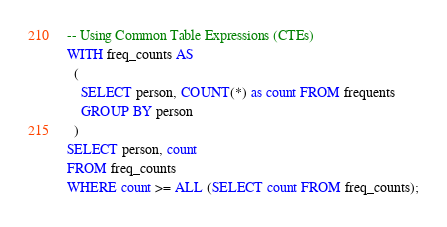<code> <loc_0><loc_0><loc_500><loc_500><_SQL_>-- Using Common Table Expressions (CTEs)
WITH freq_counts AS
  (
    SELECT person, COUNT(*) as count FROM frequents
    GROUP BY person
  )
SELECT person, count
FROM freq_counts
WHERE count >= ALL (SELECT count FROM freq_counts);</code> 